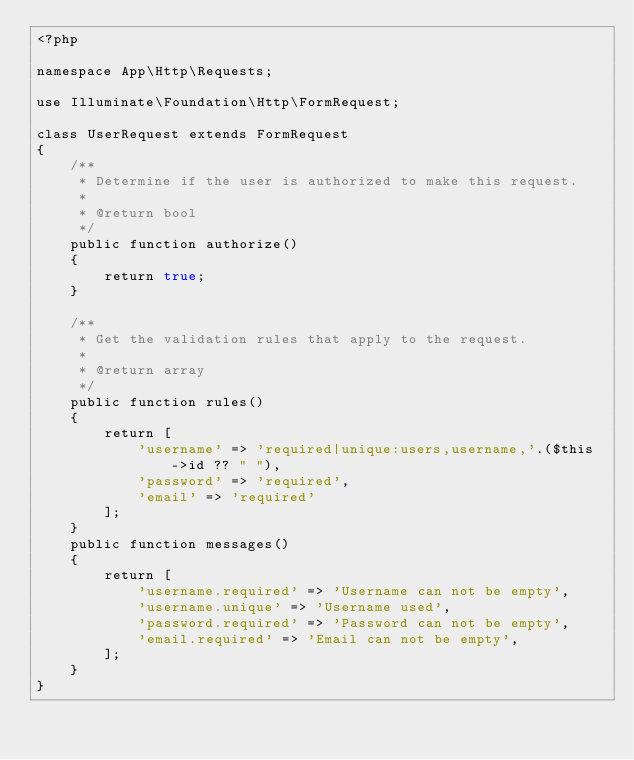Convert code to text. <code><loc_0><loc_0><loc_500><loc_500><_PHP_><?php

namespace App\Http\Requests;

use Illuminate\Foundation\Http\FormRequest;

class UserRequest extends FormRequest
{
    /**
     * Determine if the user is authorized to make this request.
     *
     * @return bool
     */
    public function authorize()
    {
        return true;
    }

    /**
     * Get the validation rules that apply to the request.
     *
     * @return array
     */
    public function rules()
    {
        return [
            'username' => 'required|unique:users,username,'.($this->id ?? " "),
            'password' => 'required',
            'email' => 'required'
        ];
    }
    public function messages()
    {
        return [
            'username.required' => 'Username can not be empty',
            'username.unique' => 'Username used',
            'password.required' => 'Password can not be empty',
            'email.required' => 'Email can not be empty',
        ];
    }
}
</code> 